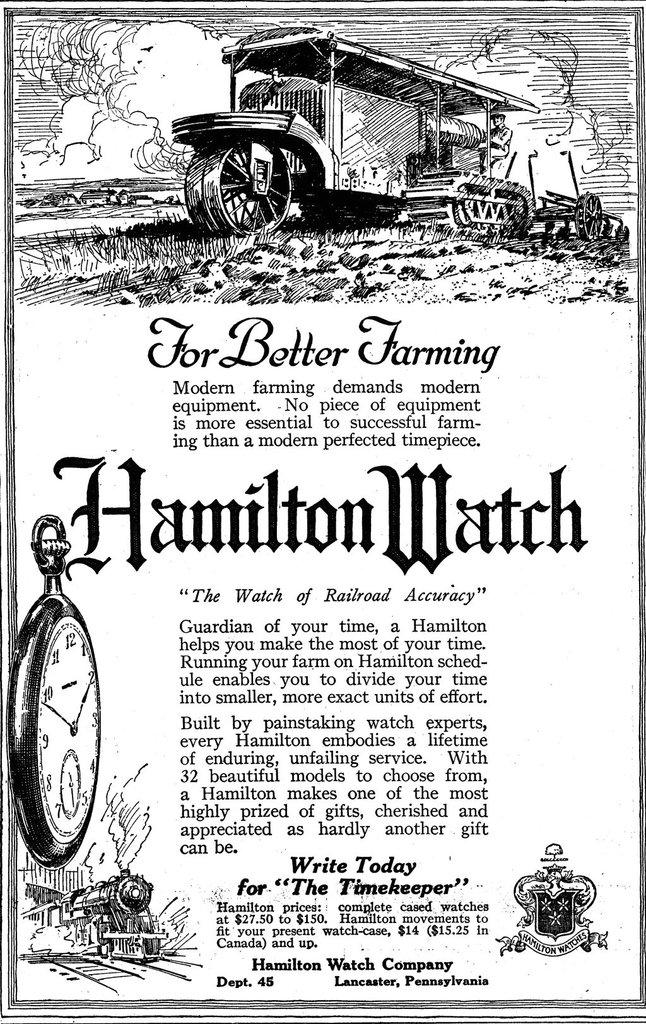<image>
Describe the image concisely. An ad for Hamilton watches says that they make for better farming. 